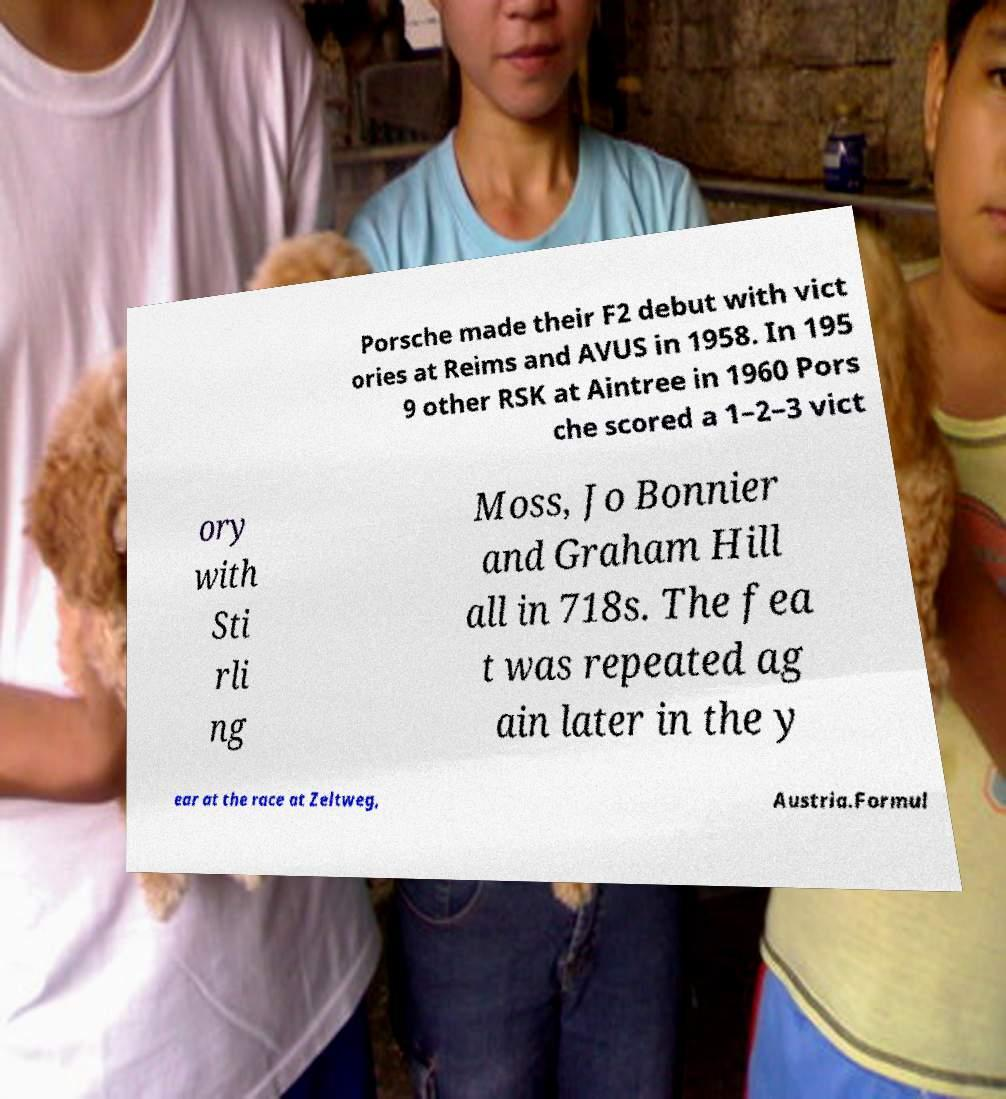What messages or text are displayed in this image? I need them in a readable, typed format. Porsche made their F2 debut with vict ories at Reims and AVUS in 1958. In 195 9 other RSK at Aintree in 1960 Pors che scored a 1–2–3 vict ory with Sti rli ng Moss, Jo Bonnier and Graham Hill all in 718s. The fea t was repeated ag ain later in the y ear at the race at Zeltweg, Austria.Formul 